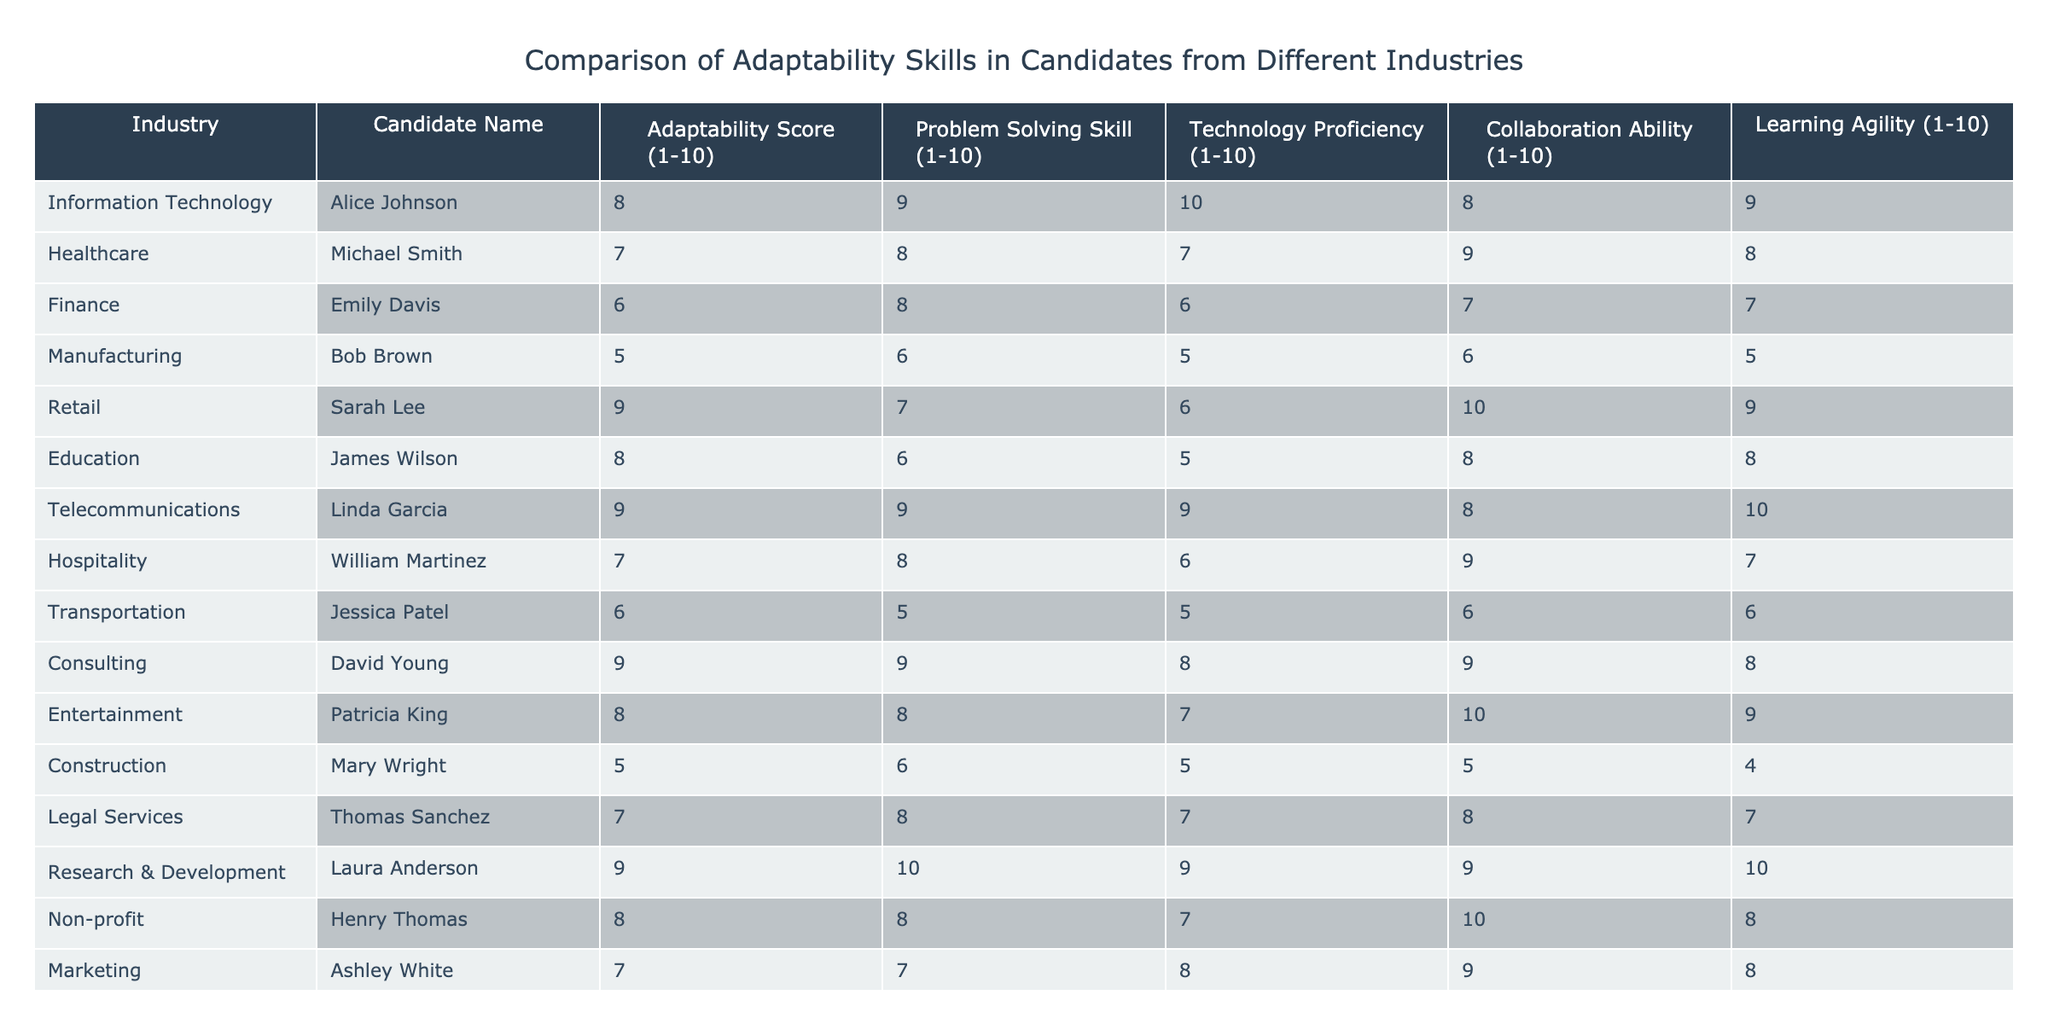What is the highest adaptability score among the candidates? After reviewing the adaptability scores, Linda Garcia and Laura Anderson both have the highest score of 9.
Answer: 9 Which candidate from the Education industry has an adaptability score? The candidate from the Education industry is James Wilson, and his adaptability score is 8.
Answer: 8 What is the average problem-solving skill score across all candidates? To find the average, sum the problem-solving scores: (9 + 8 + 8 + 6 + 7 + 6 + 9 + 8 + 5 + 9 + 8 + 8 + 7 + 7) = 100. There are 14 candidates, so the average is 100 / 14 ≈ 7.14.
Answer: 7.14 Is there any candidate in the Manufacturing industry with an adaptability score above 6? Bob Brown from the Manufacturing industry has an adaptability score of 5, which is below 6.
Answer: No List the names of candidates from the Telecommunications and Healthcare industries. The candidate from Telecommunications is Linda Garcia, and the one from Healthcare is Michael Smith. Their scores confirm their identities.
Answer: Linda Garcia, Michael Smith How many candidates have a technology proficiency score of 8 or higher? The candidates with a technology proficiency score of 8 or higher are Alice Johnson, Linda Garcia, David Young, Laura Anderson, and Ashley White. This results in a total of 5 candidates.
Answer: 5 Which industry has the lowest average adaptability score? The Manufacturing industry has an adaptability score of 5, while other industries have higher averages. Therefore, it holds the lowest score.
Answer: Manufacturing Who scored the highest in Learning Agility and what was their score? Laura Anderson has the highest score in Learning Agility with a score of 10.
Answer: Laura Anderson, 10 Are there candidates from the Non-profit and Retail industries with scores above average in adaptability? The average adaptability score is approximately 7.14. Henry Thomas from Non-profit (8) and Sarah Lee from Retail (9) both exceed this average.
Answer: Yes Which industry has the highest scoring candidate in Technology Proficiency? In terms of Technology Proficiency, Linda Garcia from Telecommunications has a score of 9, which is the highest.
Answer: Telecommunications 